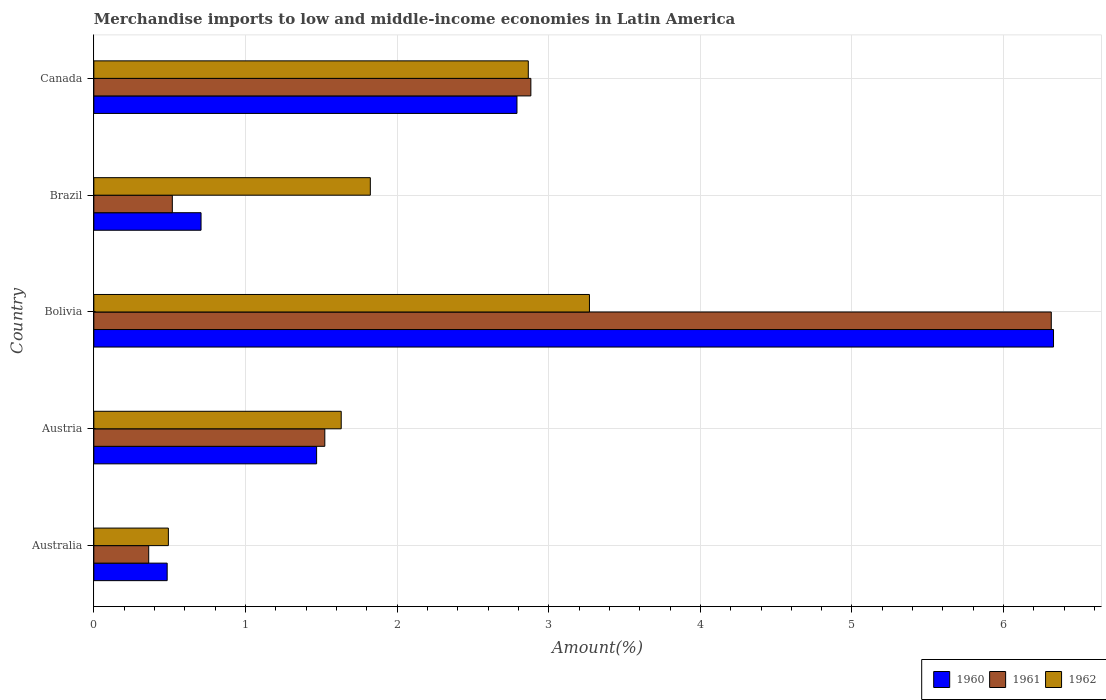Are the number of bars on each tick of the Y-axis equal?
Ensure brevity in your answer.  Yes. How many bars are there on the 2nd tick from the top?
Keep it short and to the point. 3. What is the percentage of amount earned from merchandise imports in 1962 in Bolivia?
Offer a very short reply. 3.27. Across all countries, what is the maximum percentage of amount earned from merchandise imports in 1961?
Your answer should be compact. 6.31. Across all countries, what is the minimum percentage of amount earned from merchandise imports in 1961?
Keep it short and to the point. 0.36. In which country was the percentage of amount earned from merchandise imports in 1960 maximum?
Offer a very short reply. Bolivia. What is the total percentage of amount earned from merchandise imports in 1960 in the graph?
Your answer should be very brief. 11.78. What is the difference between the percentage of amount earned from merchandise imports in 1962 in Australia and that in Brazil?
Offer a very short reply. -1.33. What is the difference between the percentage of amount earned from merchandise imports in 1960 in Bolivia and the percentage of amount earned from merchandise imports in 1962 in Australia?
Your response must be concise. 5.84. What is the average percentage of amount earned from merchandise imports in 1961 per country?
Give a very brief answer. 2.32. What is the difference between the percentage of amount earned from merchandise imports in 1961 and percentage of amount earned from merchandise imports in 1960 in Brazil?
Give a very brief answer. -0.19. In how many countries, is the percentage of amount earned from merchandise imports in 1960 greater than 6.2 %?
Provide a succinct answer. 1. What is the ratio of the percentage of amount earned from merchandise imports in 1962 in Bolivia to that in Brazil?
Provide a succinct answer. 1.79. What is the difference between the highest and the second highest percentage of amount earned from merchandise imports in 1961?
Your answer should be compact. 3.43. What is the difference between the highest and the lowest percentage of amount earned from merchandise imports in 1960?
Provide a succinct answer. 5.85. Is the sum of the percentage of amount earned from merchandise imports in 1961 in Bolivia and Brazil greater than the maximum percentage of amount earned from merchandise imports in 1962 across all countries?
Ensure brevity in your answer.  Yes. What does the 1st bar from the top in Brazil represents?
Your answer should be very brief. 1962. Is it the case that in every country, the sum of the percentage of amount earned from merchandise imports in 1962 and percentage of amount earned from merchandise imports in 1961 is greater than the percentage of amount earned from merchandise imports in 1960?
Provide a succinct answer. Yes. How many bars are there?
Ensure brevity in your answer.  15. Are all the bars in the graph horizontal?
Keep it short and to the point. Yes. What is the difference between two consecutive major ticks on the X-axis?
Your answer should be compact. 1. Does the graph contain any zero values?
Provide a succinct answer. No. Where does the legend appear in the graph?
Give a very brief answer. Bottom right. How many legend labels are there?
Give a very brief answer. 3. How are the legend labels stacked?
Make the answer very short. Horizontal. What is the title of the graph?
Ensure brevity in your answer.  Merchandise imports to low and middle-income economies in Latin America. What is the label or title of the X-axis?
Ensure brevity in your answer.  Amount(%). What is the label or title of the Y-axis?
Provide a short and direct response. Country. What is the Amount(%) of 1960 in Australia?
Give a very brief answer. 0.48. What is the Amount(%) of 1961 in Australia?
Your answer should be very brief. 0.36. What is the Amount(%) in 1962 in Australia?
Your answer should be very brief. 0.49. What is the Amount(%) of 1960 in Austria?
Your answer should be compact. 1.47. What is the Amount(%) in 1961 in Austria?
Your response must be concise. 1.52. What is the Amount(%) of 1962 in Austria?
Make the answer very short. 1.63. What is the Amount(%) of 1960 in Bolivia?
Keep it short and to the point. 6.33. What is the Amount(%) of 1961 in Bolivia?
Offer a terse response. 6.31. What is the Amount(%) in 1962 in Bolivia?
Your answer should be very brief. 3.27. What is the Amount(%) of 1960 in Brazil?
Provide a succinct answer. 0.71. What is the Amount(%) of 1961 in Brazil?
Keep it short and to the point. 0.52. What is the Amount(%) of 1962 in Brazil?
Your response must be concise. 1.82. What is the Amount(%) in 1960 in Canada?
Your response must be concise. 2.79. What is the Amount(%) in 1961 in Canada?
Offer a very short reply. 2.88. What is the Amount(%) of 1962 in Canada?
Ensure brevity in your answer.  2.87. Across all countries, what is the maximum Amount(%) of 1960?
Keep it short and to the point. 6.33. Across all countries, what is the maximum Amount(%) of 1961?
Your answer should be very brief. 6.31. Across all countries, what is the maximum Amount(%) of 1962?
Offer a very short reply. 3.27. Across all countries, what is the minimum Amount(%) of 1960?
Keep it short and to the point. 0.48. Across all countries, what is the minimum Amount(%) in 1961?
Offer a terse response. 0.36. Across all countries, what is the minimum Amount(%) of 1962?
Keep it short and to the point. 0.49. What is the total Amount(%) in 1960 in the graph?
Ensure brevity in your answer.  11.78. What is the total Amount(%) in 1961 in the graph?
Ensure brevity in your answer.  11.6. What is the total Amount(%) of 1962 in the graph?
Your answer should be compact. 10.08. What is the difference between the Amount(%) in 1960 in Australia and that in Austria?
Provide a succinct answer. -0.99. What is the difference between the Amount(%) of 1961 in Australia and that in Austria?
Give a very brief answer. -1.16. What is the difference between the Amount(%) of 1962 in Australia and that in Austria?
Make the answer very short. -1.14. What is the difference between the Amount(%) of 1960 in Australia and that in Bolivia?
Give a very brief answer. -5.85. What is the difference between the Amount(%) in 1961 in Australia and that in Bolivia?
Make the answer very short. -5.95. What is the difference between the Amount(%) of 1962 in Australia and that in Bolivia?
Ensure brevity in your answer.  -2.78. What is the difference between the Amount(%) in 1960 in Australia and that in Brazil?
Make the answer very short. -0.22. What is the difference between the Amount(%) in 1961 in Australia and that in Brazil?
Offer a terse response. -0.16. What is the difference between the Amount(%) of 1962 in Australia and that in Brazil?
Provide a short and direct response. -1.33. What is the difference between the Amount(%) in 1960 in Australia and that in Canada?
Offer a very short reply. -2.31. What is the difference between the Amount(%) in 1961 in Australia and that in Canada?
Your response must be concise. -2.52. What is the difference between the Amount(%) in 1962 in Australia and that in Canada?
Offer a terse response. -2.37. What is the difference between the Amount(%) in 1960 in Austria and that in Bolivia?
Your answer should be compact. -4.86. What is the difference between the Amount(%) of 1961 in Austria and that in Bolivia?
Provide a succinct answer. -4.79. What is the difference between the Amount(%) in 1962 in Austria and that in Bolivia?
Ensure brevity in your answer.  -1.64. What is the difference between the Amount(%) of 1960 in Austria and that in Brazil?
Your answer should be compact. 0.76. What is the difference between the Amount(%) in 1961 in Austria and that in Brazil?
Keep it short and to the point. 1.01. What is the difference between the Amount(%) in 1962 in Austria and that in Brazil?
Ensure brevity in your answer.  -0.19. What is the difference between the Amount(%) in 1960 in Austria and that in Canada?
Provide a short and direct response. -1.32. What is the difference between the Amount(%) of 1961 in Austria and that in Canada?
Your answer should be very brief. -1.36. What is the difference between the Amount(%) of 1962 in Austria and that in Canada?
Provide a short and direct response. -1.23. What is the difference between the Amount(%) in 1960 in Bolivia and that in Brazil?
Offer a very short reply. 5.62. What is the difference between the Amount(%) of 1961 in Bolivia and that in Brazil?
Offer a very short reply. 5.8. What is the difference between the Amount(%) in 1962 in Bolivia and that in Brazil?
Your answer should be compact. 1.45. What is the difference between the Amount(%) of 1960 in Bolivia and that in Canada?
Make the answer very short. 3.54. What is the difference between the Amount(%) in 1961 in Bolivia and that in Canada?
Your answer should be compact. 3.43. What is the difference between the Amount(%) in 1962 in Bolivia and that in Canada?
Provide a succinct answer. 0.4. What is the difference between the Amount(%) in 1960 in Brazil and that in Canada?
Make the answer very short. -2.08. What is the difference between the Amount(%) of 1961 in Brazil and that in Canada?
Give a very brief answer. -2.36. What is the difference between the Amount(%) in 1962 in Brazil and that in Canada?
Give a very brief answer. -1.04. What is the difference between the Amount(%) in 1960 in Australia and the Amount(%) in 1961 in Austria?
Your answer should be compact. -1.04. What is the difference between the Amount(%) of 1960 in Australia and the Amount(%) of 1962 in Austria?
Keep it short and to the point. -1.15. What is the difference between the Amount(%) of 1961 in Australia and the Amount(%) of 1962 in Austria?
Make the answer very short. -1.27. What is the difference between the Amount(%) of 1960 in Australia and the Amount(%) of 1961 in Bolivia?
Provide a short and direct response. -5.83. What is the difference between the Amount(%) in 1960 in Australia and the Amount(%) in 1962 in Bolivia?
Keep it short and to the point. -2.78. What is the difference between the Amount(%) of 1961 in Australia and the Amount(%) of 1962 in Bolivia?
Provide a succinct answer. -2.91. What is the difference between the Amount(%) of 1960 in Australia and the Amount(%) of 1961 in Brazil?
Keep it short and to the point. -0.03. What is the difference between the Amount(%) in 1960 in Australia and the Amount(%) in 1962 in Brazil?
Offer a terse response. -1.34. What is the difference between the Amount(%) of 1961 in Australia and the Amount(%) of 1962 in Brazil?
Give a very brief answer. -1.46. What is the difference between the Amount(%) of 1960 in Australia and the Amount(%) of 1961 in Canada?
Your answer should be very brief. -2.4. What is the difference between the Amount(%) in 1960 in Australia and the Amount(%) in 1962 in Canada?
Give a very brief answer. -2.38. What is the difference between the Amount(%) of 1961 in Australia and the Amount(%) of 1962 in Canada?
Provide a succinct answer. -2.5. What is the difference between the Amount(%) in 1960 in Austria and the Amount(%) in 1961 in Bolivia?
Your answer should be compact. -4.85. What is the difference between the Amount(%) in 1960 in Austria and the Amount(%) in 1962 in Bolivia?
Offer a very short reply. -1.8. What is the difference between the Amount(%) in 1961 in Austria and the Amount(%) in 1962 in Bolivia?
Your answer should be compact. -1.75. What is the difference between the Amount(%) of 1960 in Austria and the Amount(%) of 1961 in Brazil?
Keep it short and to the point. 0.95. What is the difference between the Amount(%) of 1960 in Austria and the Amount(%) of 1962 in Brazil?
Your response must be concise. -0.35. What is the difference between the Amount(%) in 1961 in Austria and the Amount(%) in 1962 in Brazil?
Keep it short and to the point. -0.3. What is the difference between the Amount(%) of 1960 in Austria and the Amount(%) of 1961 in Canada?
Offer a terse response. -1.41. What is the difference between the Amount(%) in 1960 in Austria and the Amount(%) in 1962 in Canada?
Your answer should be very brief. -1.4. What is the difference between the Amount(%) in 1961 in Austria and the Amount(%) in 1962 in Canada?
Provide a short and direct response. -1.34. What is the difference between the Amount(%) in 1960 in Bolivia and the Amount(%) in 1961 in Brazil?
Ensure brevity in your answer.  5.81. What is the difference between the Amount(%) in 1960 in Bolivia and the Amount(%) in 1962 in Brazil?
Keep it short and to the point. 4.51. What is the difference between the Amount(%) in 1961 in Bolivia and the Amount(%) in 1962 in Brazil?
Offer a terse response. 4.49. What is the difference between the Amount(%) of 1960 in Bolivia and the Amount(%) of 1961 in Canada?
Your response must be concise. 3.45. What is the difference between the Amount(%) of 1960 in Bolivia and the Amount(%) of 1962 in Canada?
Your answer should be very brief. 3.46. What is the difference between the Amount(%) in 1961 in Bolivia and the Amount(%) in 1962 in Canada?
Your answer should be compact. 3.45. What is the difference between the Amount(%) in 1960 in Brazil and the Amount(%) in 1961 in Canada?
Provide a short and direct response. -2.18. What is the difference between the Amount(%) in 1960 in Brazil and the Amount(%) in 1962 in Canada?
Offer a very short reply. -2.16. What is the difference between the Amount(%) of 1961 in Brazil and the Amount(%) of 1962 in Canada?
Your answer should be very brief. -2.35. What is the average Amount(%) in 1960 per country?
Make the answer very short. 2.36. What is the average Amount(%) of 1961 per country?
Your answer should be compact. 2.32. What is the average Amount(%) in 1962 per country?
Provide a succinct answer. 2.02. What is the difference between the Amount(%) of 1960 and Amount(%) of 1961 in Australia?
Your answer should be very brief. 0.12. What is the difference between the Amount(%) in 1960 and Amount(%) in 1962 in Australia?
Provide a short and direct response. -0.01. What is the difference between the Amount(%) of 1961 and Amount(%) of 1962 in Australia?
Ensure brevity in your answer.  -0.13. What is the difference between the Amount(%) of 1960 and Amount(%) of 1961 in Austria?
Your answer should be very brief. -0.05. What is the difference between the Amount(%) of 1960 and Amount(%) of 1962 in Austria?
Make the answer very short. -0.16. What is the difference between the Amount(%) in 1961 and Amount(%) in 1962 in Austria?
Provide a succinct answer. -0.11. What is the difference between the Amount(%) of 1960 and Amount(%) of 1961 in Bolivia?
Your answer should be very brief. 0.01. What is the difference between the Amount(%) in 1960 and Amount(%) in 1962 in Bolivia?
Keep it short and to the point. 3.06. What is the difference between the Amount(%) of 1961 and Amount(%) of 1962 in Bolivia?
Give a very brief answer. 3.05. What is the difference between the Amount(%) in 1960 and Amount(%) in 1961 in Brazil?
Provide a short and direct response. 0.19. What is the difference between the Amount(%) in 1960 and Amount(%) in 1962 in Brazil?
Give a very brief answer. -1.12. What is the difference between the Amount(%) of 1961 and Amount(%) of 1962 in Brazil?
Offer a terse response. -1.31. What is the difference between the Amount(%) in 1960 and Amount(%) in 1961 in Canada?
Provide a short and direct response. -0.09. What is the difference between the Amount(%) in 1960 and Amount(%) in 1962 in Canada?
Your response must be concise. -0.07. What is the difference between the Amount(%) of 1961 and Amount(%) of 1962 in Canada?
Provide a succinct answer. 0.02. What is the ratio of the Amount(%) in 1960 in Australia to that in Austria?
Your answer should be compact. 0.33. What is the ratio of the Amount(%) in 1961 in Australia to that in Austria?
Ensure brevity in your answer.  0.24. What is the ratio of the Amount(%) of 1962 in Australia to that in Austria?
Give a very brief answer. 0.3. What is the ratio of the Amount(%) of 1960 in Australia to that in Bolivia?
Your answer should be compact. 0.08. What is the ratio of the Amount(%) in 1961 in Australia to that in Bolivia?
Offer a very short reply. 0.06. What is the ratio of the Amount(%) in 1962 in Australia to that in Bolivia?
Provide a short and direct response. 0.15. What is the ratio of the Amount(%) of 1960 in Australia to that in Brazil?
Your answer should be compact. 0.68. What is the ratio of the Amount(%) of 1961 in Australia to that in Brazil?
Offer a terse response. 0.7. What is the ratio of the Amount(%) in 1962 in Australia to that in Brazil?
Provide a succinct answer. 0.27. What is the ratio of the Amount(%) in 1960 in Australia to that in Canada?
Your answer should be compact. 0.17. What is the ratio of the Amount(%) of 1961 in Australia to that in Canada?
Keep it short and to the point. 0.13. What is the ratio of the Amount(%) of 1962 in Australia to that in Canada?
Provide a succinct answer. 0.17. What is the ratio of the Amount(%) of 1960 in Austria to that in Bolivia?
Your answer should be very brief. 0.23. What is the ratio of the Amount(%) of 1961 in Austria to that in Bolivia?
Ensure brevity in your answer.  0.24. What is the ratio of the Amount(%) in 1962 in Austria to that in Bolivia?
Your answer should be compact. 0.5. What is the ratio of the Amount(%) in 1960 in Austria to that in Brazil?
Give a very brief answer. 2.08. What is the ratio of the Amount(%) in 1961 in Austria to that in Brazil?
Your response must be concise. 2.94. What is the ratio of the Amount(%) in 1962 in Austria to that in Brazil?
Ensure brevity in your answer.  0.89. What is the ratio of the Amount(%) of 1960 in Austria to that in Canada?
Give a very brief answer. 0.53. What is the ratio of the Amount(%) of 1961 in Austria to that in Canada?
Provide a short and direct response. 0.53. What is the ratio of the Amount(%) in 1962 in Austria to that in Canada?
Offer a terse response. 0.57. What is the ratio of the Amount(%) in 1960 in Bolivia to that in Brazil?
Keep it short and to the point. 8.95. What is the ratio of the Amount(%) of 1961 in Bolivia to that in Brazil?
Your response must be concise. 12.2. What is the ratio of the Amount(%) in 1962 in Bolivia to that in Brazil?
Your answer should be very brief. 1.79. What is the ratio of the Amount(%) of 1960 in Bolivia to that in Canada?
Make the answer very short. 2.27. What is the ratio of the Amount(%) in 1961 in Bolivia to that in Canada?
Provide a succinct answer. 2.19. What is the ratio of the Amount(%) of 1962 in Bolivia to that in Canada?
Ensure brevity in your answer.  1.14. What is the ratio of the Amount(%) in 1960 in Brazil to that in Canada?
Make the answer very short. 0.25. What is the ratio of the Amount(%) in 1961 in Brazil to that in Canada?
Provide a succinct answer. 0.18. What is the ratio of the Amount(%) in 1962 in Brazil to that in Canada?
Provide a short and direct response. 0.64. What is the difference between the highest and the second highest Amount(%) of 1960?
Offer a very short reply. 3.54. What is the difference between the highest and the second highest Amount(%) in 1961?
Offer a terse response. 3.43. What is the difference between the highest and the second highest Amount(%) in 1962?
Your response must be concise. 0.4. What is the difference between the highest and the lowest Amount(%) of 1960?
Provide a short and direct response. 5.85. What is the difference between the highest and the lowest Amount(%) of 1961?
Give a very brief answer. 5.95. What is the difference between the highest and the lowest Amount(%) in 1962?
Ensure brevity in your answer.  2.78. 